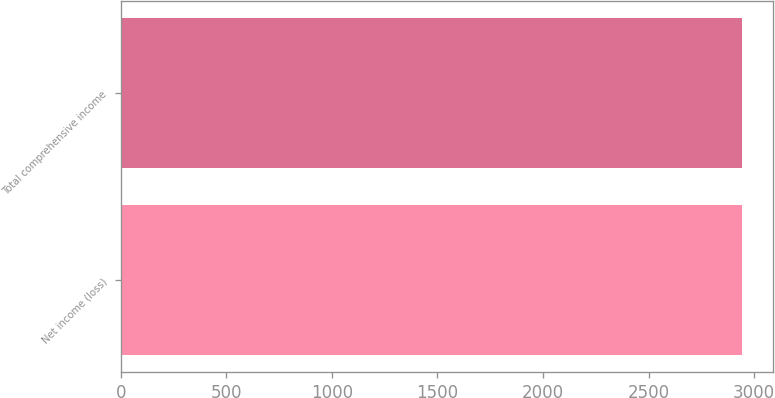<chart> <loc_0><loc_0><loc_500><loc_500><bar_chart><fcel>Net income (loss)<fcel>Total comprehensive income<nl><fcel>2944<fcel>2944.1<nl></chart> 